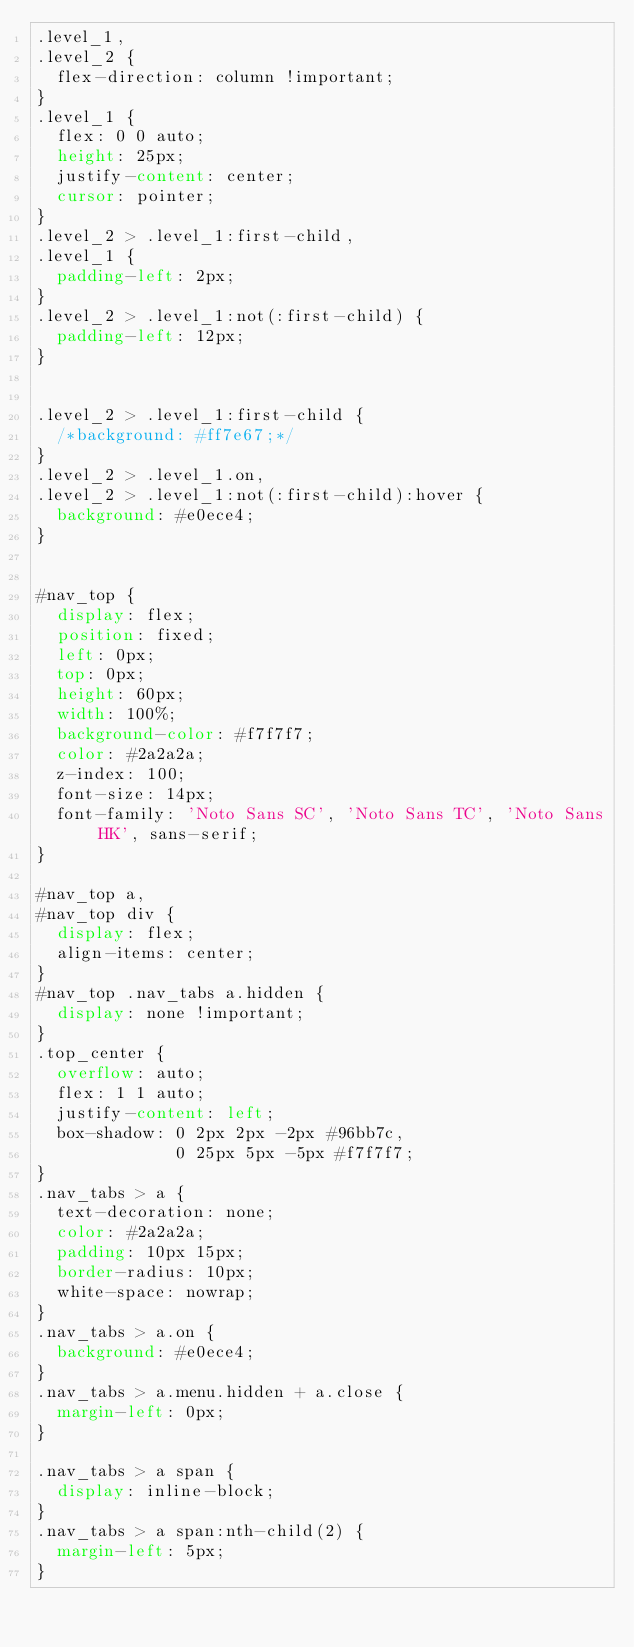Convert code to text. <code><loc_0><loc_0><loc_500><loc_500><_CSS_>.level_1,
.level_2 {
  flex-direction: column !important;
}
.level_1 {
  flex: 0 0 auto;
  height: 25px;
  justify-content: center;
  cursor: pointer;
}
.level_2 > .level_1:first-child,
.level_1 {
  padding-left: 2px;
}
.level_2 > .level_1:not(:first-child) {
  padding-left: 12px;
}


.level_2 > .level_1:first-child {
  /*background: #ff7e67;*/
}
.level_2 > .level_1.on,
.level_2 > .level_1:not(:first-child):hover {
  background: #e0ece4;
}


#nav_top {
  display: flex;
  position: fixed;
  left: 0px;
  top: 0px;
  height: 60px;
  width: 100%;
  background-color: #f7f7f7;
  color: #2a2a2a;
  z-index: 100;
  font-size: 14px;
  font-family: 'Noto Sans SC', 'Noto Sans TC', 'Noto Sans HK', sans-serif;
}

#nav_top a,
#nav_top div {
  display: flex;
  align-items: center;
}
#nav_top .nav_tabs a.hidden {
  display: none !important;
}
.top_center {
  overflow: auto;
  flex: 1 1 auto;
  justify-content: left;
  box-shadow: 0 2px 2px -2px #96bb7c,
              0 25px 5px -5px #f7f7f7;
}
.nav_tabs > a {
  text-decoration: none;
  color: #2a2a2a;
  padding: 10px 15px;
  border-radius: 10px;
  white-space: nowrap;
}
.nav_tabs > a.on {
  background: #e0ece4;
}
.nav_tabs > a.menu.hidden + a.close {
  margin-left: 0px;
}

.nav_tabs > a span {
  display: inline-block;
}
.nav_tabs > a span:nth-child(2) {
  margin-left: 5px;
}
</code> 